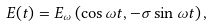<formula> <loc_0><loc_0><loc_500><loc_500>E ( t ) = E _ { \omega } \left ( \cos \omega t , - \sigma \sin \omega t \right ) ,</formula> 